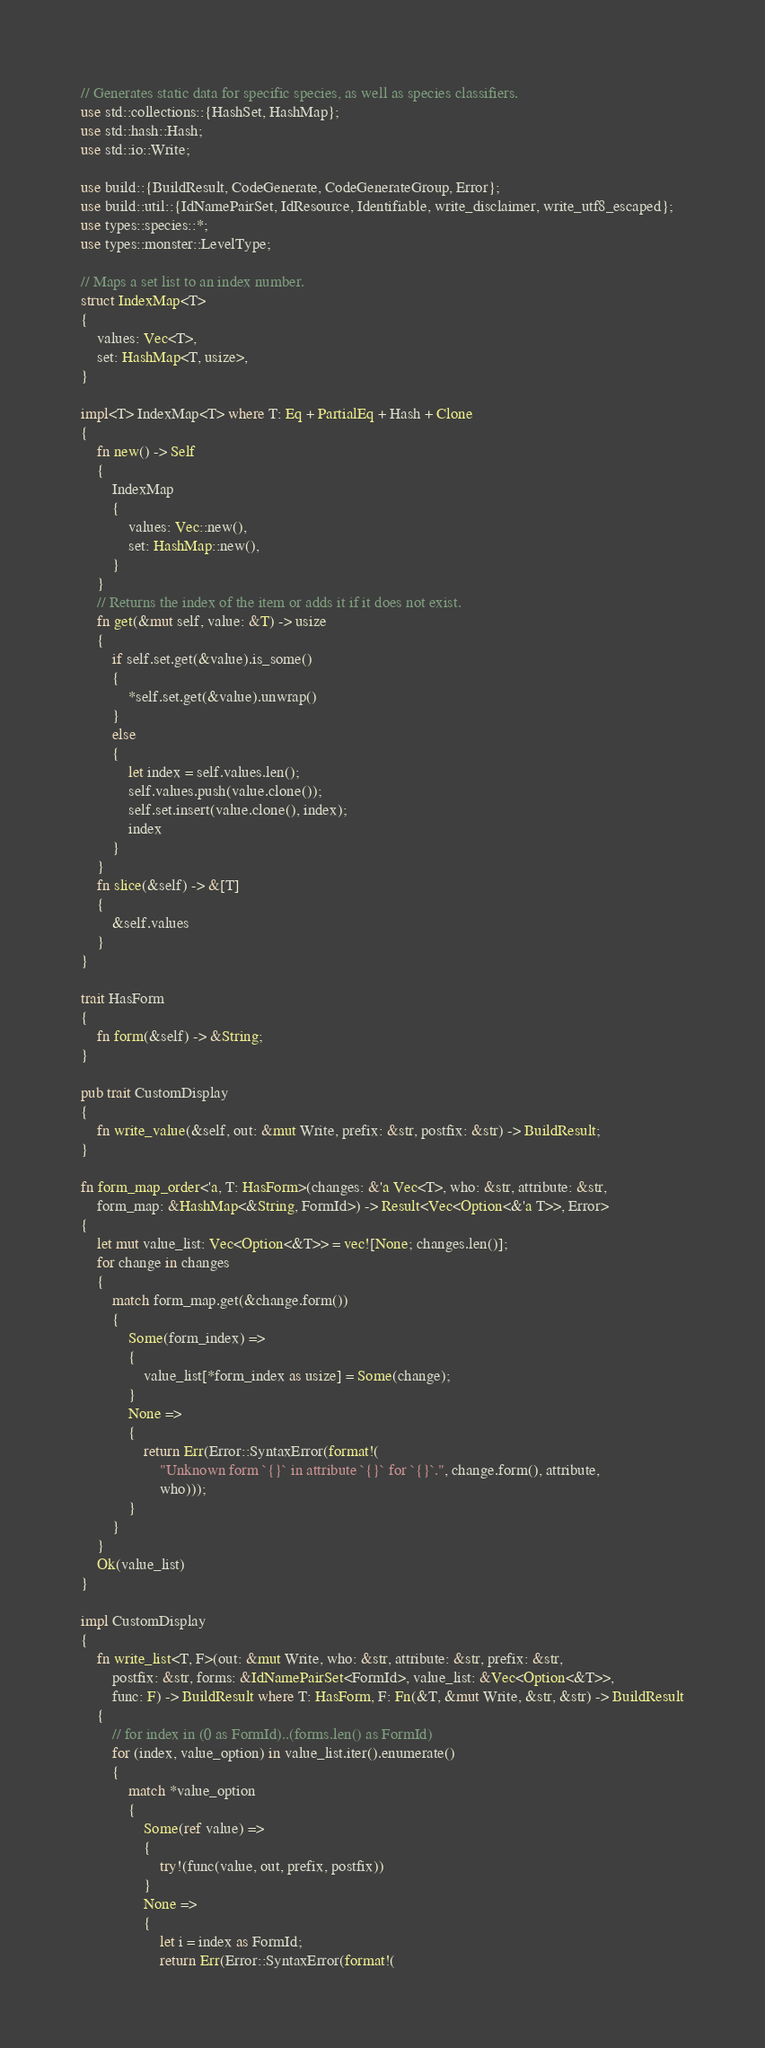Convert code to text. <code><loc_0><loc_0><loc_500><loc_500><_Rust_>// Generates static data for specific species, as well as species classifiers.
use std::collections::{HashSet, HashMap};
use std::hash::Hash;
use std::io::Write;

use build::{BuildResult, CodeGenerate, CodeGenerateGroup, Error};
use build::util::{IdNamePairSet, IdResource, Identifiable, write_disclaimer, write_utf8_escaped};
use types::species::*;
use types::monster::LevelType;

// Maps a set list to an index number.
struct IndexMap<T>
{
	values: Vec<T>,
	set: HashMap<T, usize>,
}

impl<T> IndexMap<T> where T: Eq + PartialEq + Hash + Clone
{
	fn new() -> Self
	{
		IndexMap
		{
			values: Vec::new(),
			set: HashMap::new(),
		}
	}
	// Returns the index of the item or adds it if it does not exist.
	fn get(&mut self, value: &T) -> usize
	{
		if self.set.get(&value).is_some()
		{
			*self.set.get(&value).unwrap()
		}
		else
		{
			let index = self.values.len();
			self.values.push(value.clone());
			self.set.insert(value.clone(), index);
			index
		}
	}
	fn slice(&self) -> &[T]
	{
		&self.values
	}
}

trait HasForm
{
	fn form(&self) -> &String;
}

pub trait CustomDisplay
{
	fn write_value(&self, out: &mut Write, prefix: &str, postfix: &str) -> BuildResult;
}

fn form_map_order<'a, T: HasForm>(changes: &'a Vec<T>, who: &str, attribute: &str,
	form_map: &HashMap<&String, FormId>) -> Result<Vec<Option<&'a T>>, Error>
{
	let mut value_list: Vec<Option<&T>> = vec![None; changes.len()];
	for change in changes
	{
		match form_map.get(&change.form())
		{
			Some(form_index) =>
			{
				value_list[*form_index as usize] = Some(change);
			}
			None =>
			{
				return Err(Error::SyntaxError(format!(
					"Unknown form `{}` in attribute `{}` for `{}`.", change.form(), attribute,
					who)));
			}
		}
	}
	Ok(value_list)
}

impl CustomDisplay
{
	fn write_list<T, F>(out: &mut Write, who: &str, attribute: &str, prefix: &str,
		postfix: &str, forms: &IdNamePairSet<FormId>, value_list: &Vec<Option<&T>>,
		func: F) -> BuildResult where T: HasForm, F: Fn(&T, &mut Write, &str, &str) -> BuildResult
	{
		// for index in (0 as FormId)..(forms.len() as FormId)
		for (index, value_option) in value_list.iter().enumerate()
		{
			match *value_option
			{
				Some(ref value) =>
				{
					try!(func(value, out, prefix, postfix))
				}
				None =>
				{
					let i = index as FormId;
					return Err(Error::SyntaxError(format!(</code> 